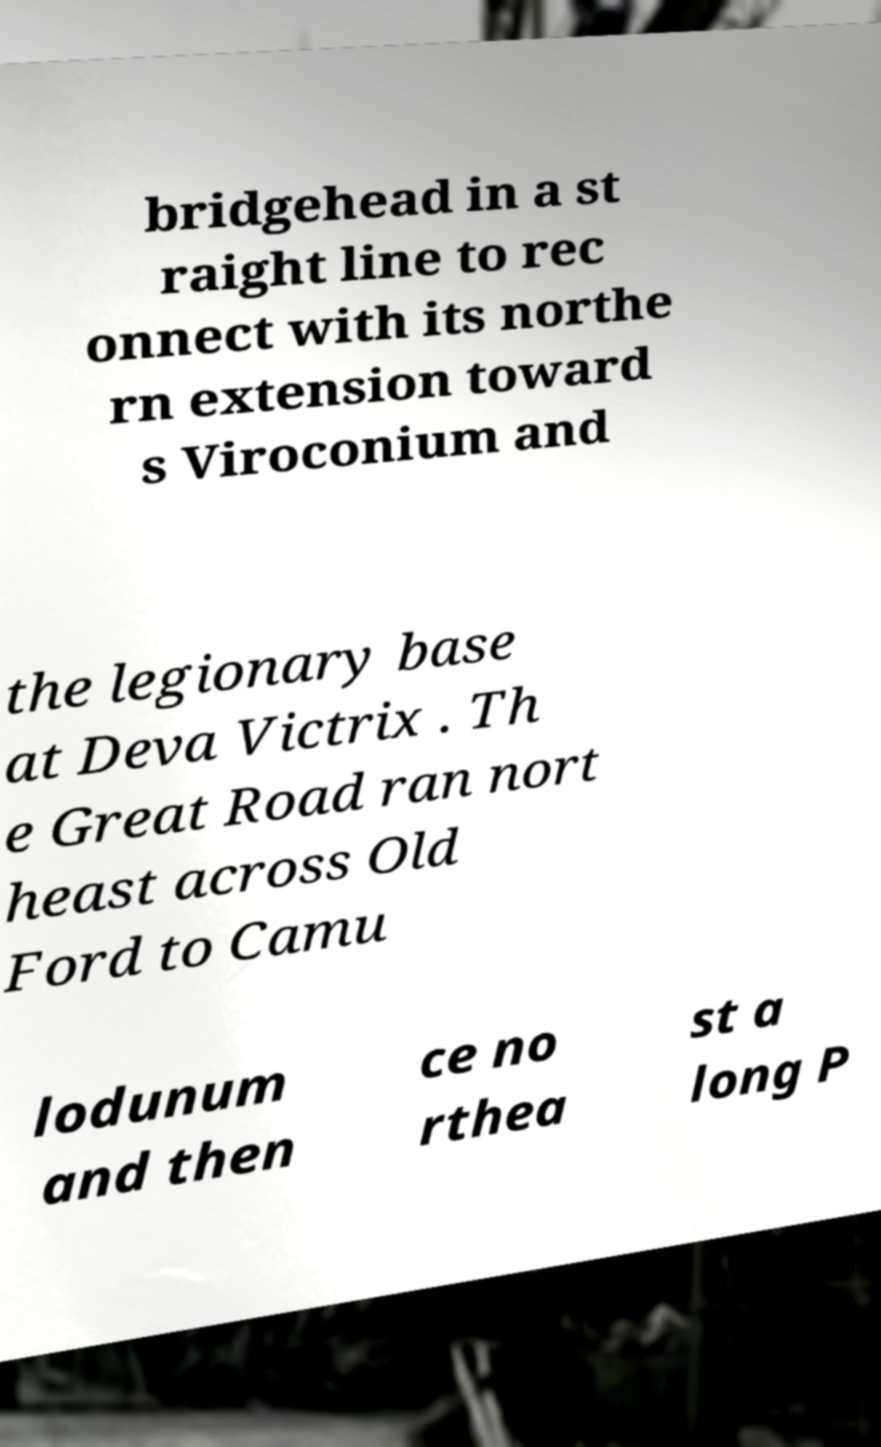Please read and relay the text visible in this image. What does it say? bridgehead in a st raight line to rec onnect with its northe rn extension toward s Viroconium and the legionary base at Deva Victrix . Th e Great Road ran nort heast across Old Ford to Camu lodunum and then ce no rthea st a long P 